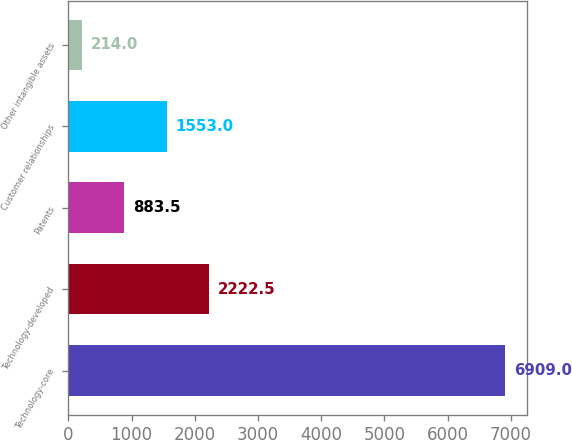Convert chart. <chart><loc_0><loc_0><loc_500><loc_500><bar_chart><fcel>Technology-core<fcel>Technology-developed<fcel>Patents<fcel>Customer relationships<fcel>Other intangible assets<nl><fcel>6909<fcel>2222.5<fcel>883.5<fcel>1553<fcel>214<nl></chart> 